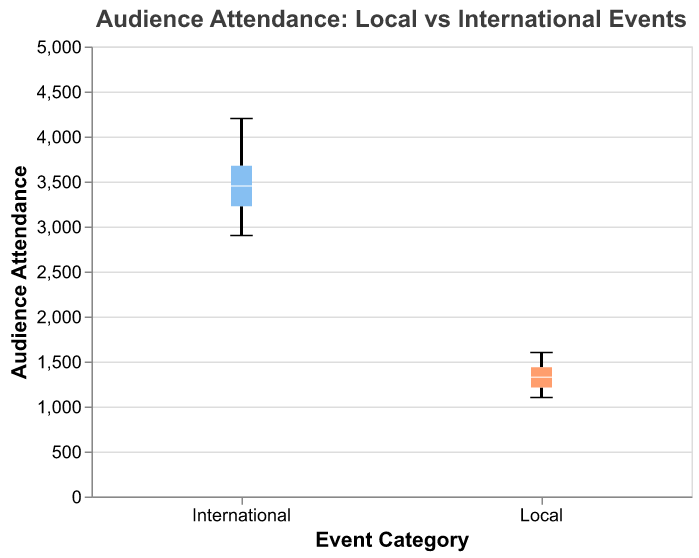What's the title of the plot? The title of the plot is often displayed at the top and is bold and larger in font size compared to other text elements in the plot. The title helps to immediately convey the subject of the plot.
Answer: "Audience Attendance: Local vs International Events" What are the two categories being compared in the plot? The categories being compared in the plot can be seen on the x-axis, where two different labels would be present.
Answer: Local and International What is the range of audience attendance for international events? The range of audience attendance is represented by the extent of the whiskers in the box plot for the International category. You can identify the minimum and maximum values along the y-axis.
Answer: 2900 to 4200 Which category has a greater median attendance? The median attendance is shown as a line inside each box in the box plot. Comparing the position of the median lines for both categories shows which one is higher.
Answer: International What is the median attendance for local events? The median attendance is indicated by the line inside the box for the Local category. Locate this line's position on the y-axis.
Answer: 1300 Which category has the highest outlier value? Outliers, if present, are typically plotted as individual points outside the whiskers. Identify the category for which the point extends furthest on the y-axis.
Answer: International How do the interquartile ranges (IQR) of local and international events compare? The interquartile range (IQR) is represented by the height of the box in the box plot. Compare the height of the boxes for Local and International categories to determine which is larger.
Answer: International has a larger IQR Are there any overlaps in the range of audience attendance between local and international events? Check if the whiskers of the boxes for Local and International categories have any overlapping range on the y-axis.
Answer: Yes, there is overlap between 2900 and 1600 What is the minimum attendance for local events? The minimum attendance is indicated by the lower whisker end for the Local category.
Answer: 1100 Is the variance in audience attendance higher for local or international events? The variance can be inferred by the spread of the data points, represented by the whiskers and the width of the boxes. The greater the spread, the higher the variance.
Answer: International 